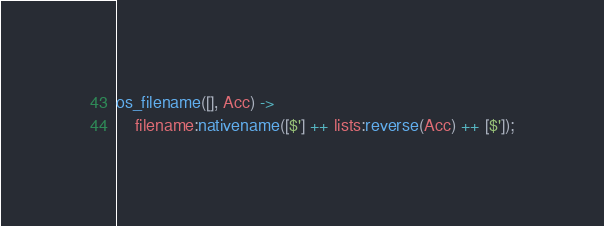<code> <loc_0><loc_0><loc_500><loc_500><_Erlang_>
os_filename([], Acc) ->
    filename:nativename([$'] ++ lists:reverse(Acc) ++ [$']);</code> 